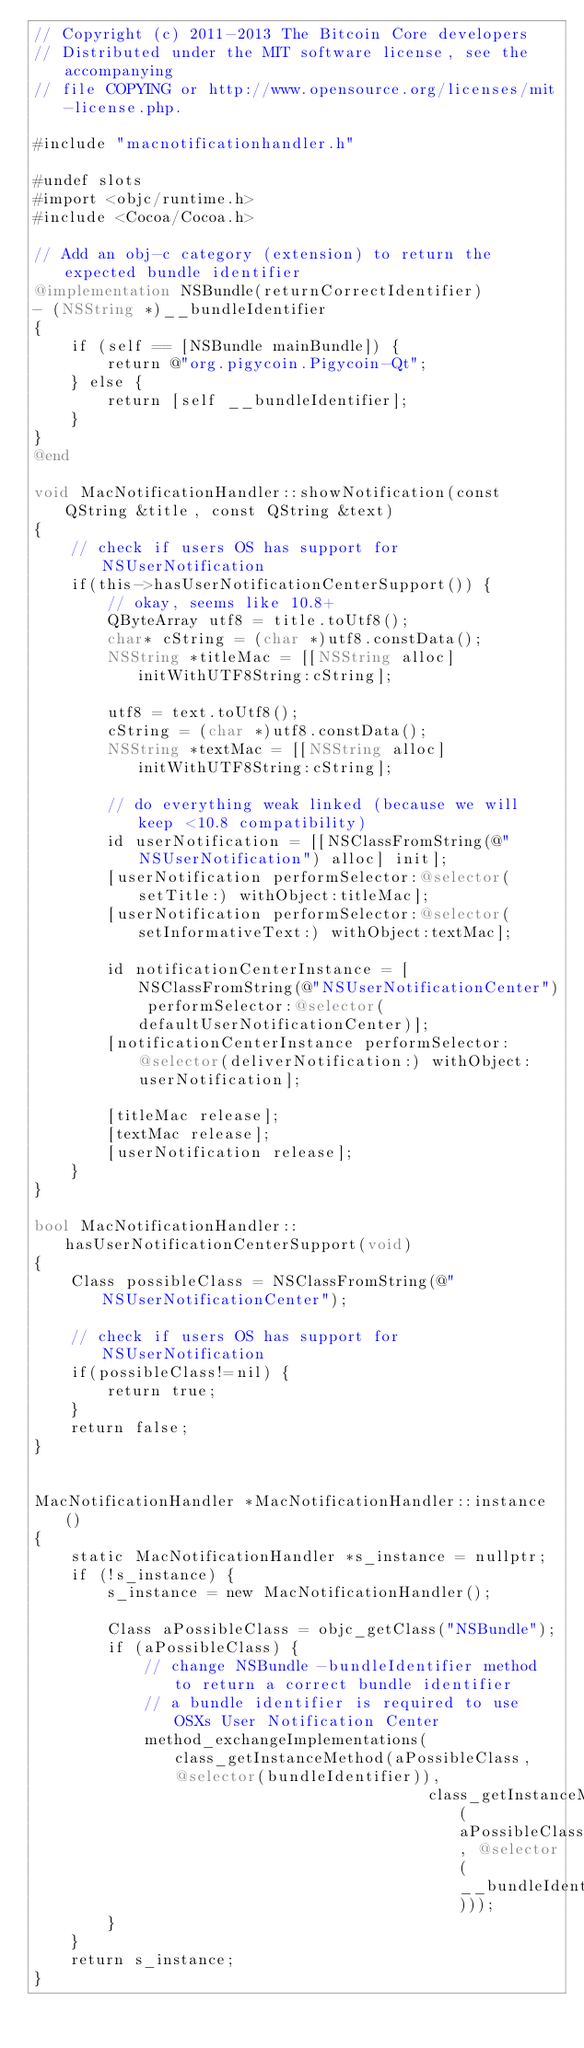<code> <loc_0><loc_0><loc_500><loc_500><_ObjectiveC_>// Copyright (c) 2011-2013 The Bitcoin Core developers
// Distributed under the MIT software license, see the accompanying
// file COPYING or http://www.opensource.org/licenses/mit-license.php.

#include "macnotificationhandler.h"

#undef slots
#import <objc/runtime.h>
#include <Cocoa/Cocoa.h>

// Add an obj-c category (extension) to return the expected bundle identifier
@implementation NSBundle(returnCorrectIdentifier)
- (NSString *)__bundleIdentifier
{
    if (self == [NSBundle mainBundle]) {
        return @"org.pigycoin.Pigycoin-Qt";
    } else {
        return [self __bundleIdentifier];
    }
}
@end

void MacNotificationHandler::showNotification(const QString &title, const QString &text)
{
    // check if users OS has support for NSUserNotification
    if(this->hasUserNotificationCenterSupport()) {
        // okay, seems like 10.8+
        QByteArray utf8 = title.toUtf8();
        char* cString = (char *)utf8.constData();
        NSString *titleMac = [[NSString alloc] initWithUTF8String:cString];

        utf8 = text.toUtf8();
        cString = (char *)utf8.constData();
        NSString *textMac = [[NSString alloc] initWithUTF8String:cString];

        // do everything weak linked (because we will keep <10.8 compatibility)
        id userNotification = [[NSClassFromString(@"NSUserNotification") alloc] init];
        [userNotification performSelector:@selector(setTitle:) withObject:titleMac];
        [userNotification performSelector:@selector(setInformativeText:) withObject:textMac];

        id notificationCenterInstance = [NSClassFromString(@"NSUserNotificationCenter") performSelector:@selector(defaultUserNotificationCenter)];
        [notificationCenterInstance performSelector:@selector(deliverNotification:) withObject:userNotification];

        [titleMac release];
        [textMac release];
        [userNotification release];
    }
}

bool MacNotificationHandler::hasUserNotificationCenterSupport(void)
{
    Class possibleClass = NSClassFromString(@"NSUserNotificationCenter");

    // check if users OS has support for NSUserNotification
    if(possibleClass!=nil) {
        return true;
    }
    return false;
}


MacNotificationHandler *MacNotificationHandler::instance()
{
    static MacNotificationHandler *s_instance = nullptr;
    if (!s_instance) {
        s_instance = new MacNotificationHandler();

        Class aPossibleClass = objc_getClass("NSBundle");
        if (aPossibleClass) {
            // change NSBundle -bundleIdentifier method to return a correct bundle identifier
            // a bundle identifier is required to use OSXs User Notification Center
            method_exchangeImplementations(class_getInstanceMethod(aPossibleClass, @selector(bundleIdentifier)),
                                           class_getInstanceMethod(aPossibleClass, @selector(__bundleIdentifier)));
        }
    }
    return s_instance;
}
</code> 